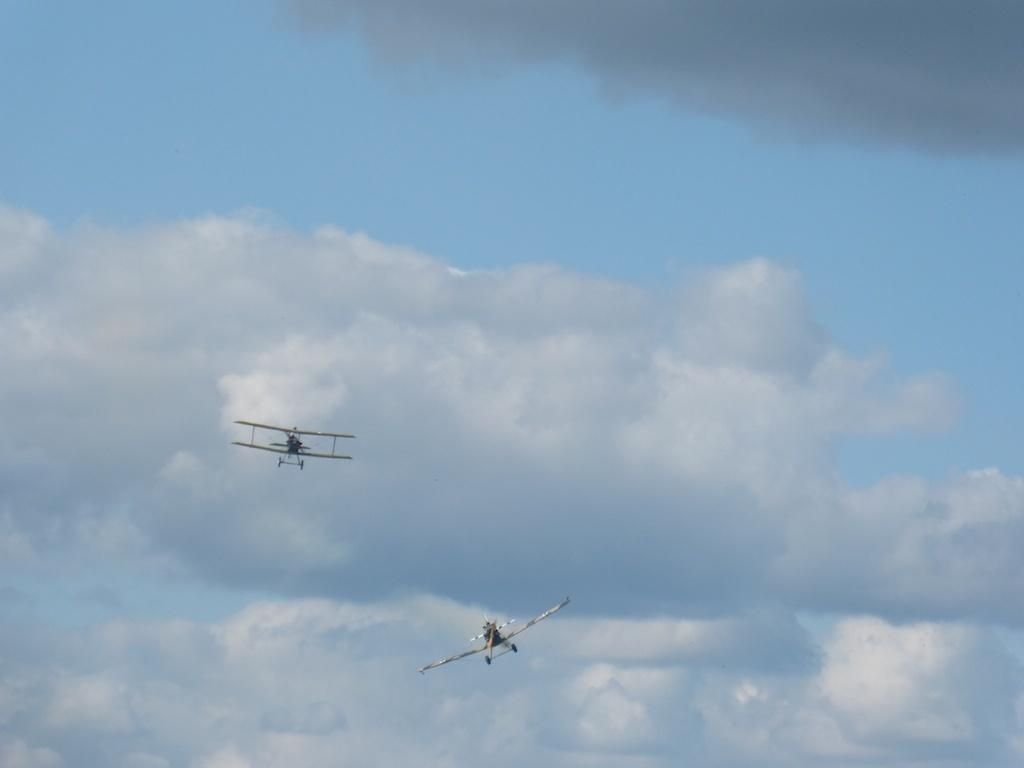What is the main subject of the image? The main subject of the image is two airplanes. Where are the airplanes located in the image? The airplanes are in the foreground of the image. What is the condition of the airplanes in the image? The airplanes are in the air. What can be seen in the background of the image? There is the sky visible in the background of the image. What is the weather like in the image? The presence of clouds in the sky suggests that it is partly cloudy. What type of bat can be seen flying alongside the airplanes in the image? There are no bats present in the image; it features two airplanes in the air. What type of journey are the airplanes on in the image? The image does not provide any information about the journey or destination of the airplanes. 